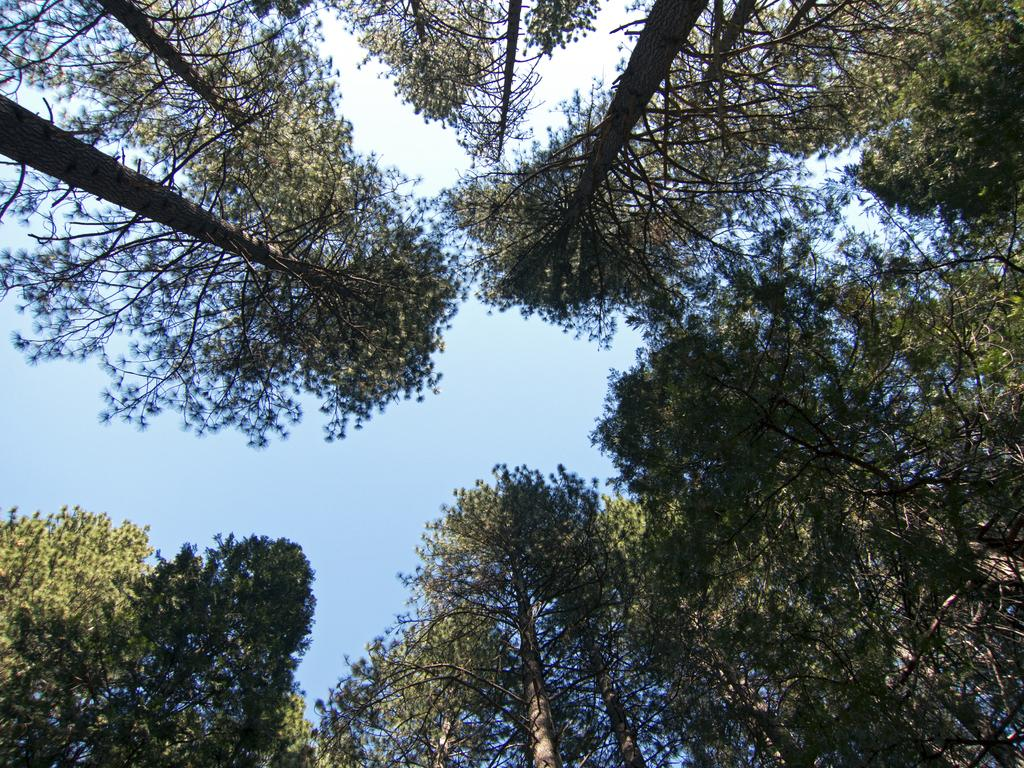What is the orientation of the image? The image is taken from the bottom to the top. What type of vegetation can be seen in the image? There are tall trees in the image. How are the trees arranged in the image? The trees are arranged in a circular manner. What is visible at the top of the image? The sky is visible at the top of the image. What type of fowl can be seen nesting in the trees in the image? There is no fowl visible in the image; it only features tall trees arranged in a circular manner. How many oranges are present on the trees in the image? There are no oranges present in the image; it only features tall trees. 